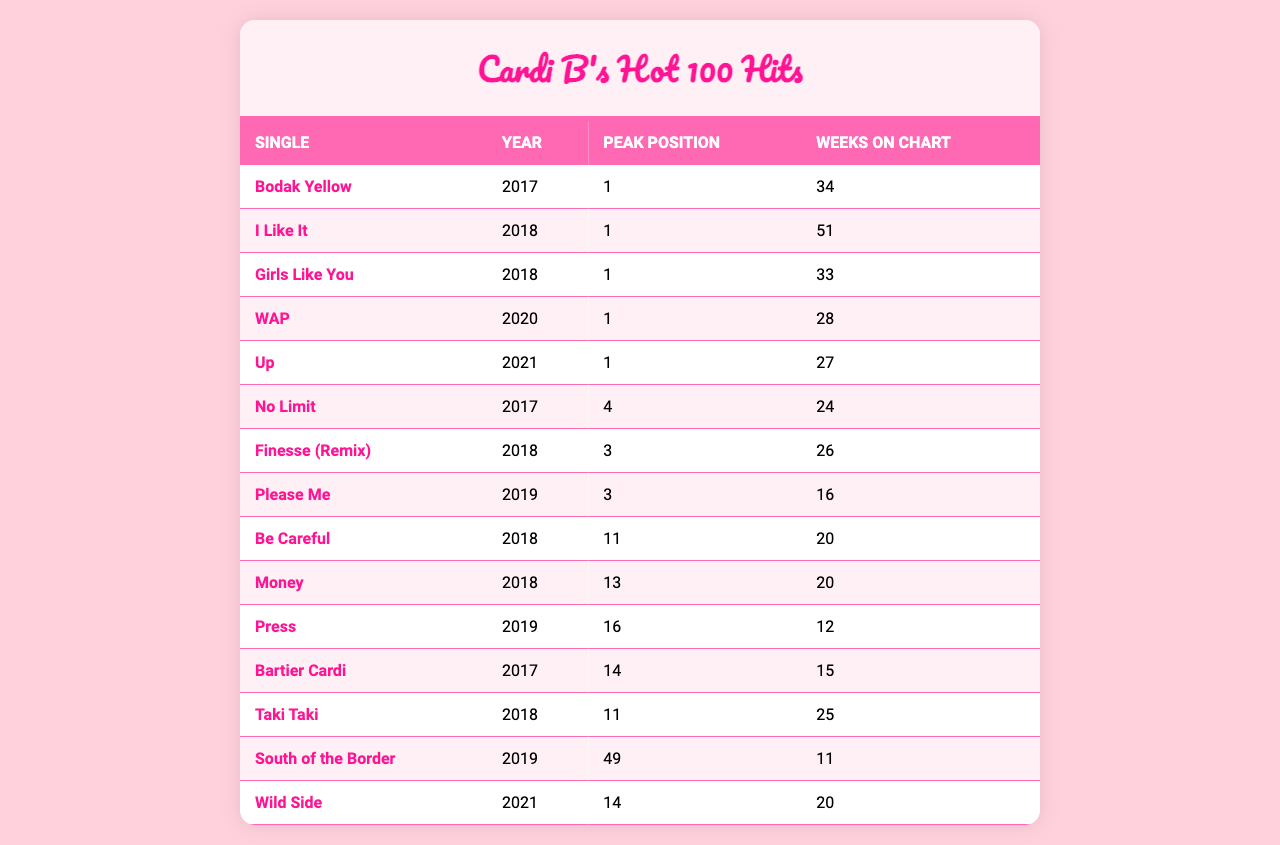What single had the highest peak position on the chart? Looking at the table, "Bodak Yellow," "I Like It," "Girls Like You," "WAP," and "Up" all reached the peak position of 1. However, the first one listed and also the first one to achieve this position was "Bodak Yellow" in 2017.
Answer: Bodak Yellow Which single spent the most weeks on the Billboard Hot 100? The single with the most weeks on the chart is "I Like It," which stayed on for 51 weeks.
Answer: I Like It Did "Money" reach the top 10 of the Billboard Hot 100? The table shows that "Money" reached a peak position of 13, which is just outside the top 10. Therefore, it did not reach the top 10.
Answer: No What is the average peak position of Cardi B's singles? The peak positions are: 1, 1, 1, 1, 1, 4, 3, 3, 11, 13, 16, 14, 11, 49, and 14. The average is calculated as follows: (1+1+1+1+1+4+3+3+11+13+16+14+11+49+14)/15 = 9.933.
Answer: Approximately 9.93 How many singles peaked at position 1 on the chart? From the table, we can see that five singles peaked at position 1: "Bodak Yellow," "I Like It," "Girls Like You," "WAP," and "Up."
Answer: 5 Which year had the most singles charting, and how many were there? Checking the years in the table, 2018 has the highest number of singles: "I Like It," "Finesse (Remix)," "Be Careful," "Money," "Taki Taki." That's a total of 5 singles.
Answer: 2018, 5 Was there any single that spent less than 15 weeks on the chart? Yes, both "Press" and "South of the Border" spent 12 and 11 weeks respectively, which is less than 15.
Answer: Yes Which single had the longest name and how many positions did it peak at? The single with the longest name is "South of the Border," which peaked at position 49.
Answer: South of the Border, 49 What is the total number of weeks Cardi B’s singles spent on the chart? Adding the weeks on the chart: 34 + 51 + 33 + 28 + 27 + 24 + 26 + 16 + 20 + 20 + 12 + 15 + 25 + 11 + 20 =  392 weeks in total.
Answer: 392 weeks Which of Cardi B's singles had the least success on the Billboard Hot 100 based on peak position? The single "South of the Border" reached the lowest peak position at 49.
Answer: South of the Border 